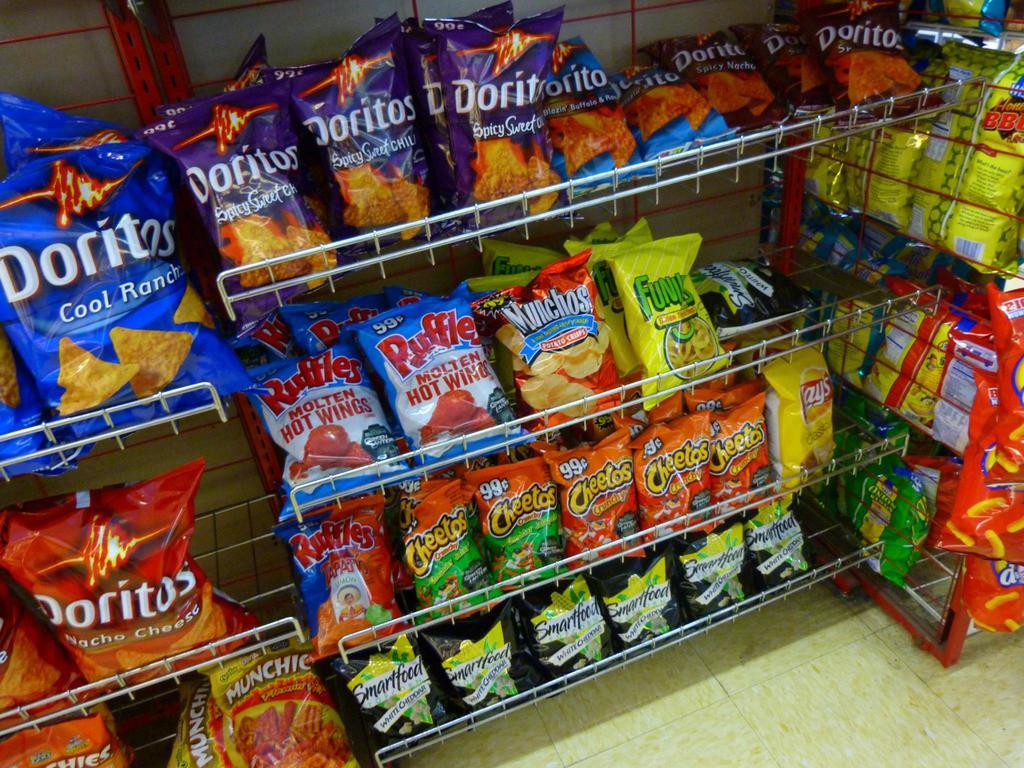What flavor of chips is in the blue bag?
Provide a succinct answer. Cool ranch. What brand of snack is in the black ba?
Your response must be concise. Smartfood. 